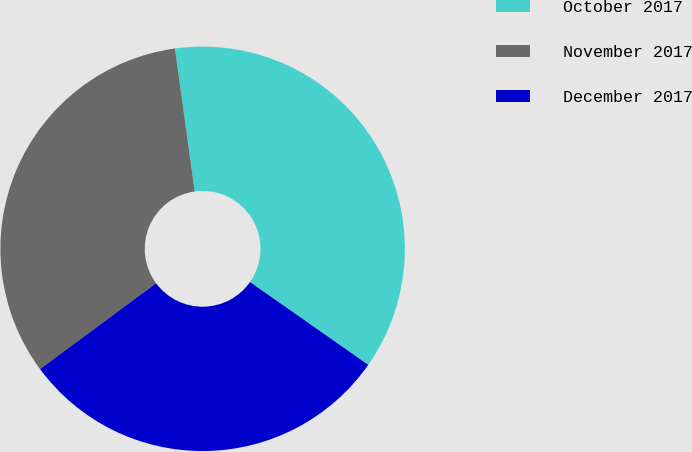Convert chart to OTSL. <chart><loc_0><loc_0><loc_500><loc_500><pie_chart><fcel>October 2017<fcel>November 2017<fcel>December 2017<nl><fcel>36.91%<fcel>32.95%<fcel>30.14%<nl></chart> 